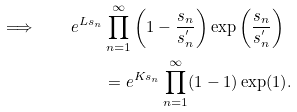<formula> <loc_0><loc_0><loc_500><loc_500>\Longrightarrow \quad e ^ { L s _ { n } } & \prod ^ { \infty } _ { n = 1 } \left ( 1 - \frac { s _ { n } } { s ^ { ^ { \prime } } _ { n } } \right ) \exp \left ( \frac { s _ { n } } { s ^ { ^ { \prime } } _ { n } } \right ) \\ & = e ^ { K s _ { n } } \prod ^ { \infty } _ { n = 1 } ( 1 - 1 ) \exp ( 1 ) .</formula> 